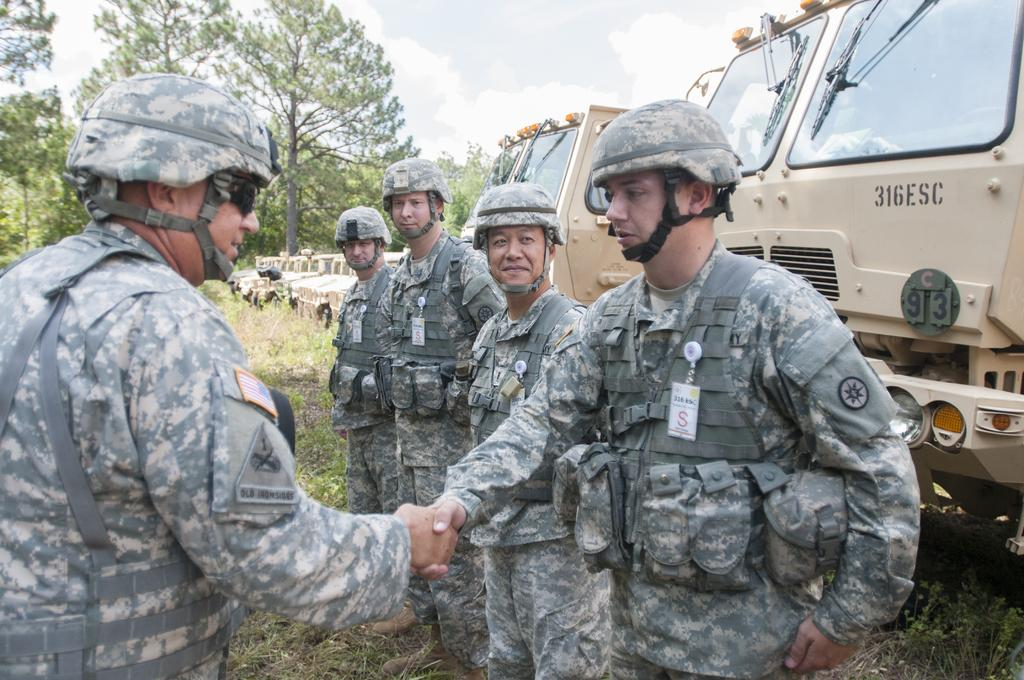<image>
Relay a brief, clear account of the picture shown. In a line of military personnel a soldier is being greeted in front of a military tuck numbered 316ESC. 